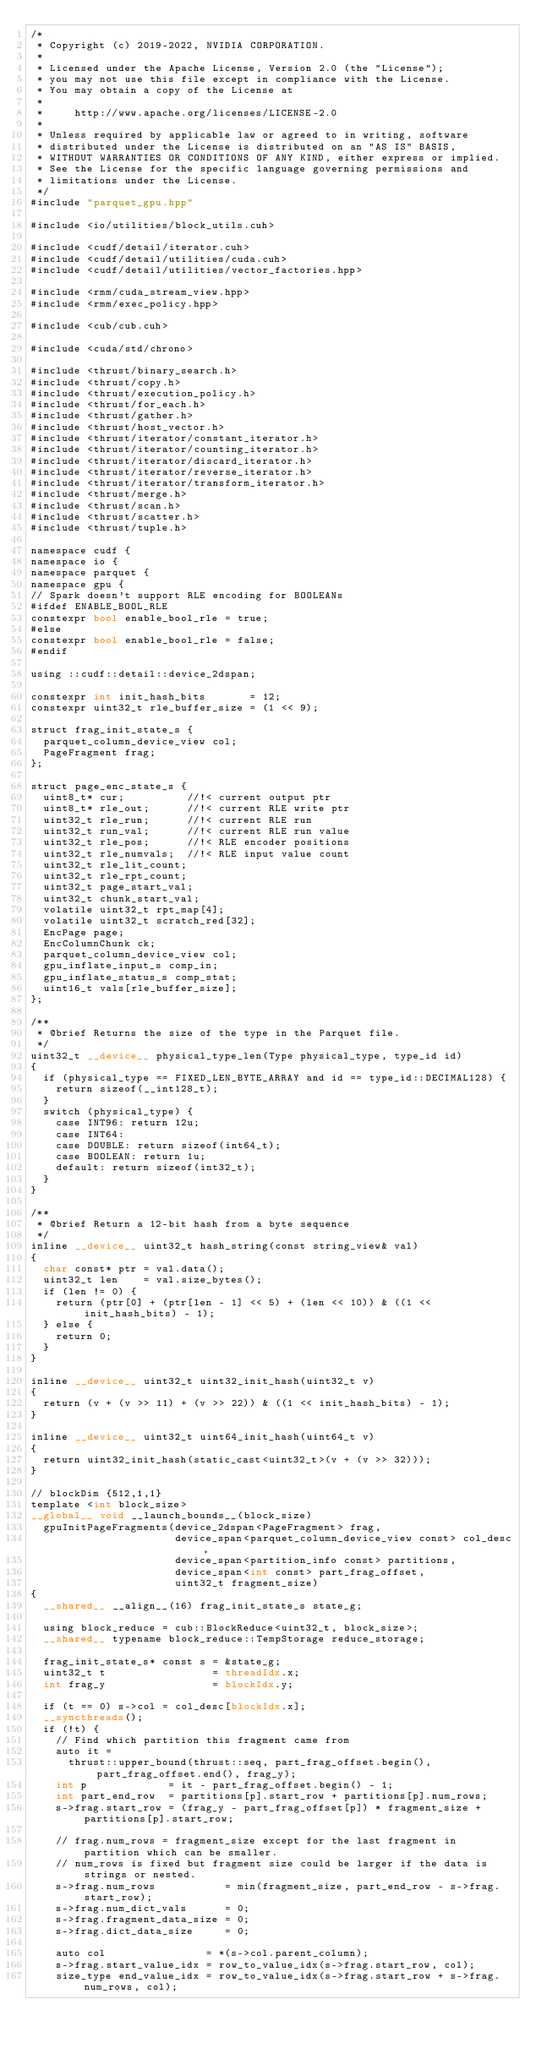Convert code to text. <code><loc_0><loc_0><loc_500><loc_500><_Cuda_>/*
 * Copyright (c) 2019-2022, NVIDIA CORPORATION.
 *
 * Licensed under the Apache License, Version 2.0 (the "License");
 * you may not use this file except in compliance with the License.
 * You may obtain a copy of the License at
 *
 *     http://www.apache.org/licenses/LICENSE-2.0
 *
 * Unless required by applicable law or agreed to in writing, software
 * distributed under the License is distributed on an "AS IS" BASIS,
 * WITHOUT WARRANTIES OR CONDITIONS OF ANY KIND, either express or implied.
 * See the License for the specific language governing permissions and
 * limitations under the License.
 */
#include "parquet_gpu.hpp"

#include <io/utilities/block_utils.cuh>

#include <cudf/detail/iterator.cuh>
#include <cudf/detail/utilities/cuda.cuh>
#include <cudf/detail/utilities/vector_factories.hpp>

#include <rmm/cuda_stream_view.hpp>
#include <rmm/exec_policy.hpp>

#include <cub/cub.cuh>

#include <cuda/std/chrono>

#include <thrust/binary_search.h>
#include <thrust/copy.h>
#include <thrust/execution_policy.h>
#include <thrust/for_each.h>
#include <thrust/gather.h>
#include <thrust/host_vector.h>
#include <thrust/iterator/constant_iterator.h>
#include <thrust/iterator/counting_iterator.h>
#include <thrust/iterator/discard_iterator.h>
#include <thrust/iterator/reverse_iterator.h>
#include <thrust/iterator/transform_iterator.h>
#include <thrust/merge.h>
#include <thrust/scan.h>
#include <thrust/scatter.h>
#include <thrust/tuple.h>

namespace cudf {
namespace io {
namespace parquet {
namespace gpu {
// Spark doesn't support RLE encoding for BOOLEANs
#ifdef ENABLE_BOOL_RLE
constexpr bool enable_bool_rle = true;
#else
constexpr bool enable_bool_rle = false;
#endif

using ::cudf::detail::device_2dspan;

constexpr int init_hash_bits       = 12;
constexpr uint32_t rle_buffer_size = (1 << 9);

struct frag_init_state_s {
  parquet_column_device_view col;
  PageFragment frag;
};

struct page_enc_state_s {
  uint8_t* cur;          //!< current output ptr
  uint8_t* rle_out;      //!< current RLE write ptr
  uint32_t rle_run;      //!< current RLE run
  uint32_t run_val;      //!< current RLE run value
  uint32_t rle_pos;      //!< RLE encoder positions
  uint32_t rle_numvals;  //!< RLE input value count
  uint32_t rle_lit_count;
  uint32_t rle_rpt_count;
  uint32_t page_start_val;
  uint32_t chunk_start_val;
  volatile uint32_t rpt_map[4];
  volatile uint32_t scratch_red[32];
  EncPage page;
  EncColumnChunk ck;
  parquet_column_device_view col;
  gpu_inflate_input_s comp_in;
  gpu_inflate_status_s comp_stat;
  uint16_t vals[rle_buffer_size];
};

/**
 * @brief Returns the size of the type in the Parquet file.
 */
uint32_t __device__ physical_type_len(Type physical_type, type_id id)
{
  if (physical_type == FIXED_LEN_BYTE_ARRAY and id == type_id::DECIMAL128) {
    return sizeof(__int128_t);
  }
  switch (physical_type) {
    case INT96: return 12u;
    case INT64:
    case DOUBLE: return sizeof(int64_t);
    case BOOLEAN: return 1u;
    default: return sizeof(int32_t);
  }
}

/**
 * @brief Return a 12-bit hash from a byte sequence
 */
inline __device__ uint32_t hash_string(const string_view& val)
{
  char const* ptr = val.data();
  uint32_t len    = val.size_bytes();
  if (len != 0) {
    return (ptr[0] + (ptr[len - 1] << 5) + (len << 10)) & ((1 << init_hash_bits) - 1);
  } else {
    return 0;
  }
}

inline __device__ uint32_t uint32_init_hash(uint32_t v)
{
  return (v + (v >> 11) + (v >> 22)) & ((1 << init_hash_bits) - 1);
}

inline __device__ uint32_t uint64_init_hash(uint64_t v)
{
  return uint32_init_hash(static_cast<uint32_t>(v + (v >> 32)));
}

// blockDim {512,1,1}
template <int block_size>
__global__ void __launch_bounds__(block_size)
  gpuInitPageFragments(device_2dspan<PageFragment> frag,
                       device_span<parquet_column_device_view const> col_desc,
                       device_span<partition_info const> partitions,
                       device_span<int const> part_frag_offset,
                       uint32_t fragment_size)
{
  __shared__ __align__(16) frag_init_state_s state_g;

  using block_reduce = cub::BlockReduce<uint32_t, block_size>;
  __shared__ typename block_reduce::TempStorage reduce_storage;

  frag_init_state_s* const s = &state_g;
  uint32_t t                 = threadIdx.x;
  int frag_y                 = blockIdx.y;

  if (t == 0) s->col = col_desc[blockIdx.x];
  __syncthreads();
  if (!t) {
    // Find which partition this fragment came from
    auto it =
      thrust::upper_bound(thrust::seq, part_frag_offset.begin(), part_frag_offset.end(), frag_y);
    int p             = it - part_frag_offset.begin() - 1;
    int part_end_row  = partitions[p].start_row + partitions[p].num_rows;
    s->frag.start_row = (frag_y - part_frag_offset[p]) * fragment_size + partitions[p].start_row;

    // frag.num_rows = fragment_size except for the last fragment in partition which can be smaller.
    // num_rows is fixed but fragment size could be larger if the data is strings or nested.
    s->frag.num_rows           = min(fragment_size, part_end_row - s->frag.start_row);
    s->frag.num_dict_vals      = 0;
    s->frag.fragment_data_size = 0;
    s->frag.dict_data_size     = 0;

    auto col                = *(s->col.parent_column);
    s->frag.start_value_idx = row_to_value_idx(s->frag.start_row, col);
    size_type end_value_idx = row_to_value_idx(s->frag.start_row + s->frag.num_rows, col);</code> 